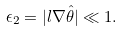<formula> <loc_0><loc_0><loc_500><loc_500>\epsilon _ { 2 } = | l { \nabla } \hat { \theta } | \ll 1 .</formula> 